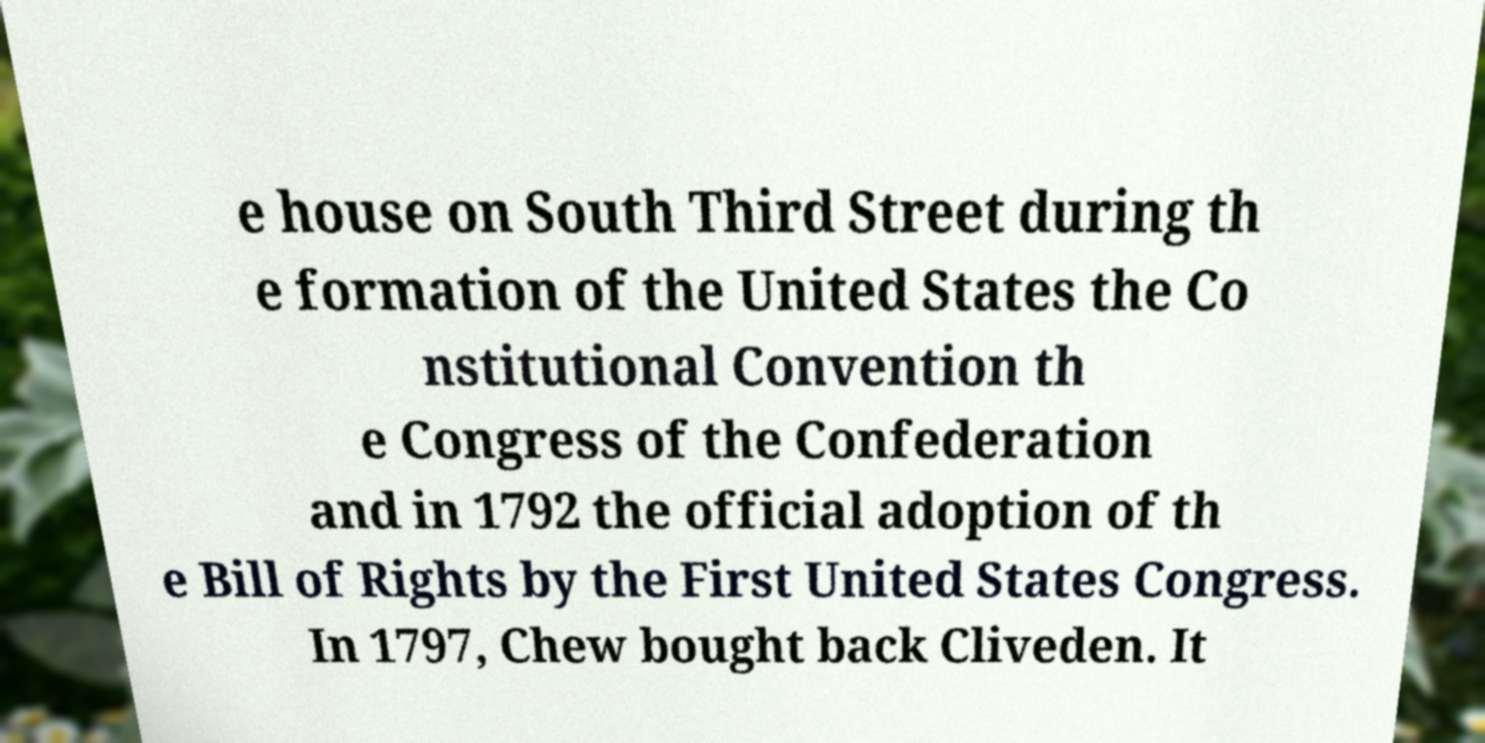Can you accurately transcribe the text from the provided image for me? e house on South Third Street during th e formation of the United States the Co nstitutional Convention th e Congress of the Confederation and in 1792 the official adoption of th e Bill of Rights by the First United States Congress. In 1797, Chew bought back Cliveden. It 